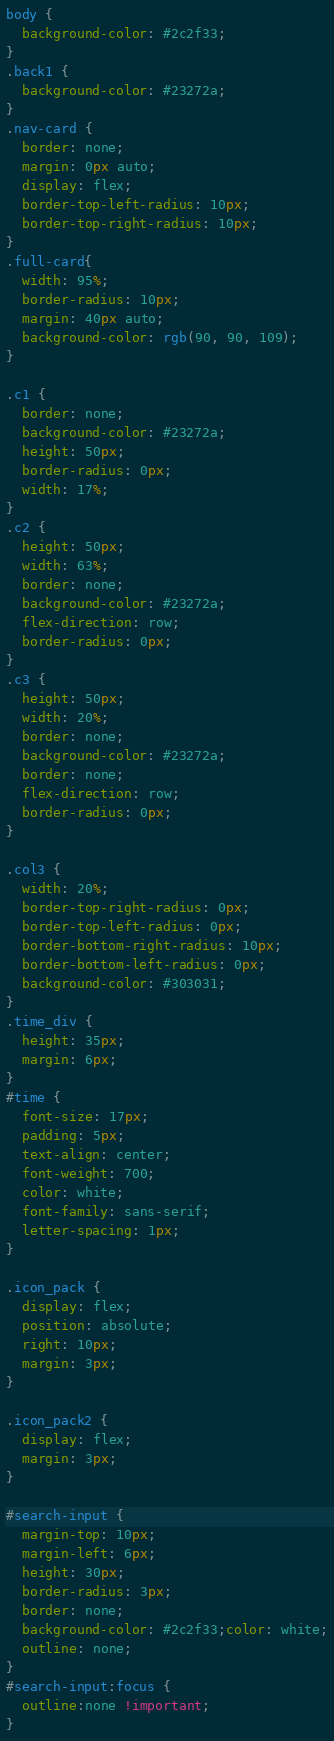Convert code to text. <code><loc_0><loc_0><loc_500><loc_500><_CSS_>body {
  background-color: #2c2f33;
}
.back1 {
  background-color: #23272a;
}
.nav-card {
  border: none;
  margin: 0px auto;
  display: flex;
  border-top-left-radius: 10px;
  border-top-right-radius: 10px;
}
.full-card{
  width: 95%;
  border-radius: 10px;
  margin: 40px auto;
  background-color: rgb(90, 90, 109);
}

.c1 {
  border: none;
  background-color: #23272a;
  height: 50px;
  border-radius: 0px;
  width: 17%;
}
.c2 {
  height: 50px;
  width: 63%;
  border: none;
  background-color: #23272a;
  flex-direction: row;
  border-radius: 0px;
}
.c3 {
  height: 50px;
  width: 20%;
  border: none;
  background-color: #23272a;
  border: none;
  flex-direction: row;
  border-radius: 0px;
}

.col3 {
  width: 20%;
  border-top-right-radius: 0px;
  border-top-left-radius: 0px;
  border-bottom-right-radius: 10px;
  border-bottom-left-radius: 0px;
  background-color: #303031;
}
.time_div {
  height: 35px;
  margin: 6px;
}
#time {
  font-size: 17px;
  padding: 5px;
  text-align: center;
  font-weight: 700;
  color: white;
  font-family: sans-serif;
  letter-spacing: 1px;
}

.icon_pack {
  display: flex;
  position: absolute;
  right: 10px;
  margin: 3px;
}

.icon_pack2 {
  display: flex;
  margin: 3px;
}

#search-input {
  margin-top: 10px;
  margin-left: 6px;
  height: 30px;
  border-radius: 3px;
  border: none;
  background-color: #2c2f33;color: white;
  outline: none;
}
#search-input:focus {
  outline:none !important;
}
</code> 